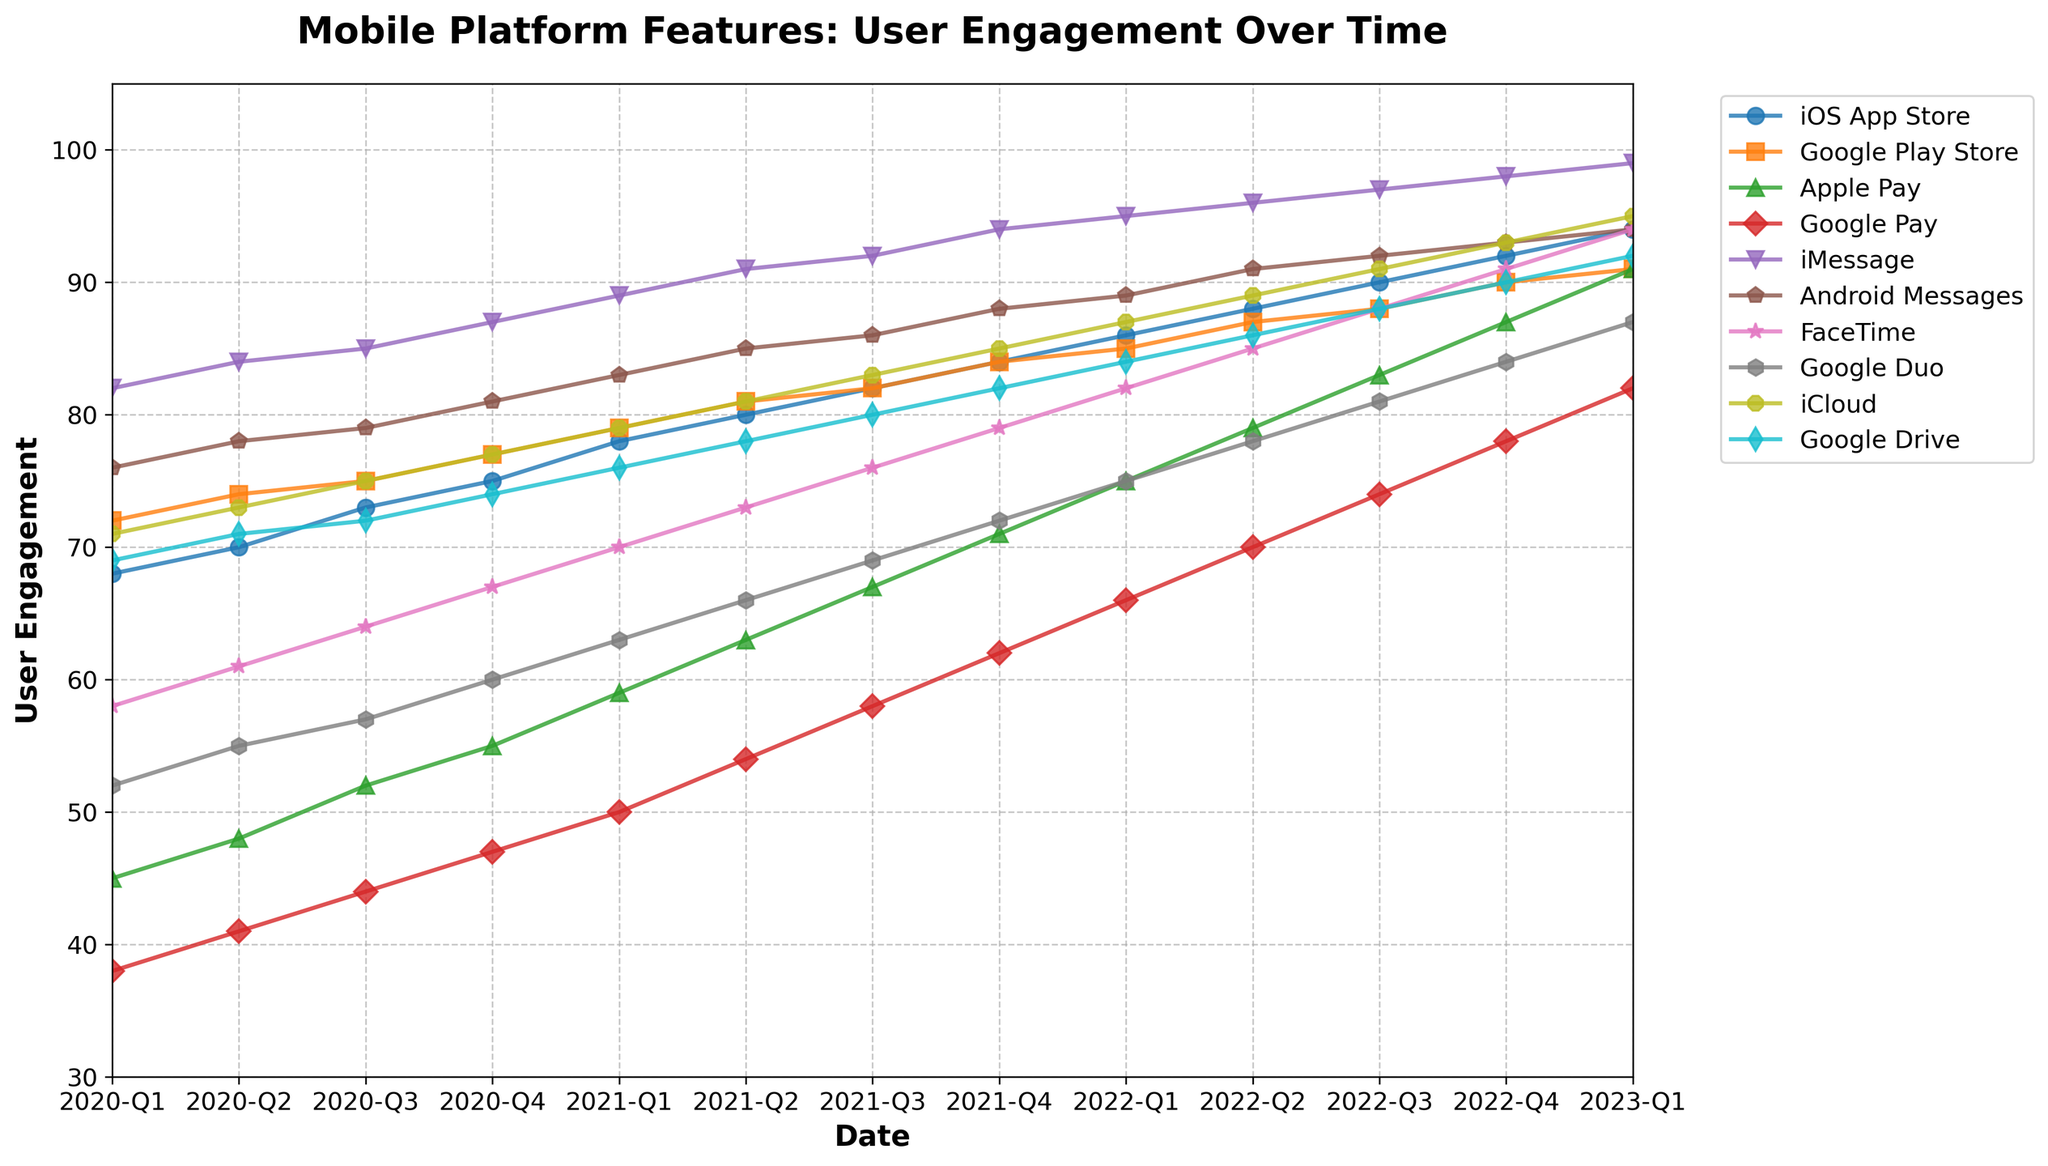What's the trend in user engagement for iOS App Store from 2020-Q1 to 2023-Q1? From the figure, we see that the user engagement for iOS App Store consistently increases each quarter. The values start at 68 in 2020-Q1 and rise steadily to 94 by 2023-Q1.
Answer: Increasing trend Which feature experienced the most significant growth in user engagement from 2020-Q1 to 2023-Q1? Comparing the starting and ending values for each feature, we notice Apple Pay grows from 45 to 91, a difference of 46 points. This is the largest growth among the features listed.
Answer: Apple Pay Between iMessage and Android Messages, which one had higher user engagement in 2021-Q3? In 2021-Q3, the user engagement for iMessage is 92 and for Android Messages is 86.
Answer: iMessage Is there any feature whose user engagement remained steady or had very little change from 2020-Q1 to 2023-Q1? All features show noticeable changes, but Google Play Store shows a smaller change compared to others, increasing from 72 to 91, resulting in a 19-point difference, which is the minimal change visible among the features.
Answer: Google Play Store What is the average user engagement for FaceTime across all quarters? To find the average, sum up the values for FaceTime across all quarters and then divide by the number of quarters. Adding the values 58, 61, 64, 67, 70, 73, 76, 79, 82, 85, 88, 91, 94 gives a total of 988. There are 13 quarters, so the average is 988 / 13 ≈ 76
Answer: 76 Which feature has the highest user engagement in 2022-Q4? In 2022-Q4, examining the values, iMessage has the highest user engagement at 98.
Answer: iMessage How does the user engagement of Google Duo in 2020-Q4 compare to that in 2021-Q4? The user engagement for Google Duo in 2020-Q4 is 60, and in 2021-Q4 it is 72. So, it increased by 12 points.
Answer: Increased by 12 points Considering only 2023-Q1, which platform features have user engagements greater than 90? In 2023-Q1, the features with more than 90 user engagement are iOS App Store (94), Apple Pay (91), iMessage (99), FaceTime (94), and Google Drive (92).
Answer: iOS App Store, Apple Pay, iMessage, FaceTime, Google Drive What is the difference in user engagement between iCloud and Google Drive in 2021-Q2? In 2021-Q2, the user engagement for iCloud is 81, and for Google Drive, it is 78. The difference between them is 81 - 78 = 3.
Answer: 3 Which feature showed the highest increase from 2022-Q1 to 2023-Q1? Comparing values from 2022-Q1 to 2023-Q1, Apple Pay increased from 75 to 91, which is an increase of 16 points. This is the highest increase for the given period.
Answer: Apple Pay 